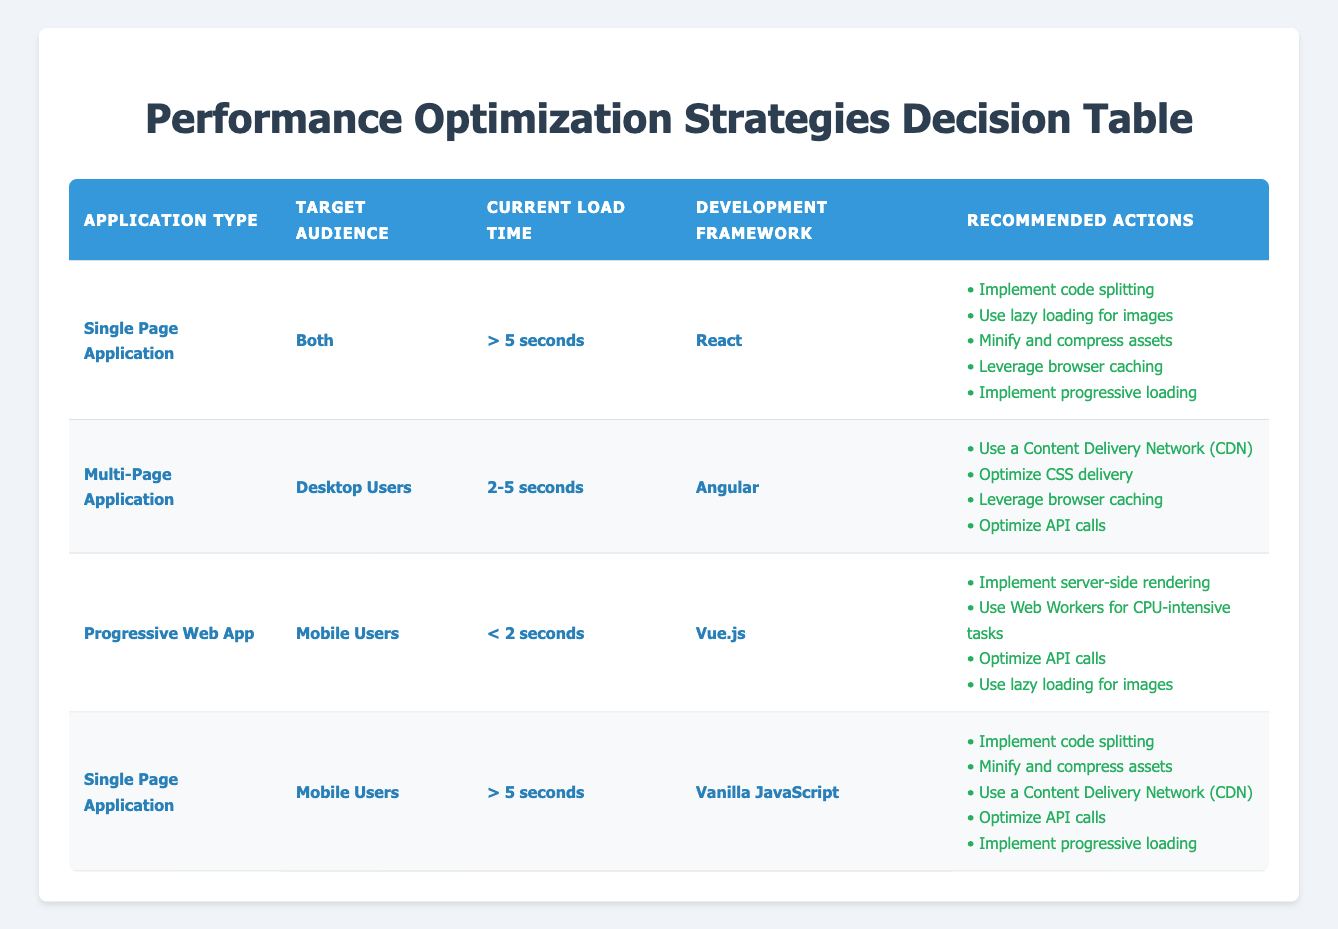What is the recommended action for a Multi-Page Application targeting Desktop Users with a load time of 2-5 seconds using Angular? In the table, look for the row where Application Type is "Multi-Page Application," Target Audience is "Desktop Users," Current Load Time is "2-5 seconds," and Development Framework is "Angular." This matches one of the rules, which lists recommended actions such as using a Content Delivery Network, optimizing CSS delivery, leveraging browser caching, and optimizing API calls.
Answer: Use a Content Delivery Network, Optimize CSS delivery, Leverage browser caching, Optimize API calls For Single Page Applications targeting both audiences with a load time over 5 seconds using React, how many actions are recommended? Check the row where Application Type is "Single Page Application," Target Audience is "Both," Current Load Time is "> 5 seconds," and Development Framework is "React." This particular entry has five recommended actions listed.
Answer: 5 Is using Web Workers a recommended action for Progressive Web Apps targeting Mobile Users with a load time less than 2 seconds using Vue.js? Look at the row for Progressive Web App, where the Target Audience is "Mobile Users," Current Load Time is "< 2 seconds," and Development Framework is "Vue.js." This row includes using Web Workers for CPU-intensive tasks as a recommended action, hence the answer is true.
Answer: Yes How many different frameworks have recommended actions listed in the given table? To answer this, consider all unique Development Framework values across the table: React, Angular, Vue.js, and Vanilla JavaScript, which totals four different frameworks.
Answer: 4 Which recommended action is common in both rows for Single Page Applications where the load time is greater than 5 seconds? Focus on the rows for Single Page Applications, checking both the row for "React" and for "Vanilla JavaScript," both of which list "Implement code splitting" as a shared recommended action.
Answer: Implement code splitting What is the difference in the number of recommended actions between the Multi-Page Application and Progressive Web App? The row for the Multi-Page Application has four recommended actions, while the Progressive Web App row has four recommended actions as well. Calculating the difference yields zero.
Answer: 0 